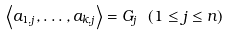<formula> <loc_0><loc_0><loc_500><loc_500>\left \langle a _ { 1 , j } , \dots , a _ { k , j } \right \rangle = G _ { j } \text { } ( 1 \leq j \leq n )</formula> 